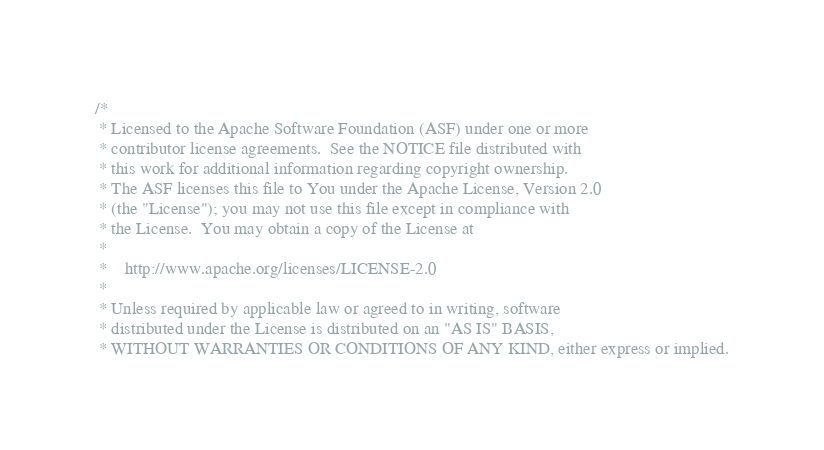<code> <loc_0><loc_0><loc_500><loc_500><_Scala_>/*
 * Licensed to the Apache Software Foundation (ASF) under one or more
 * contributor license agreements.  See the NOTICE file distributed with
 * this work for additional information regarding copyright ownership.
 * The ASF licenses this file to You under the Apache License, Version 2.0
 * (the "License"); you may not use this file except in compliance with
 * the License.  You may obtain a copy of the License at
 *
 *    http://www.apache.org/licenses/LICENSE-2.0
 *
 * Unless required by applicable law or agreed to in writing, software
 * distributed under the License is distributed on an "AS IS" BASIS,
 * WITHOUT WARRANTIES OR CONDITIONS OF ANY KIND, either express or implied.</code> 